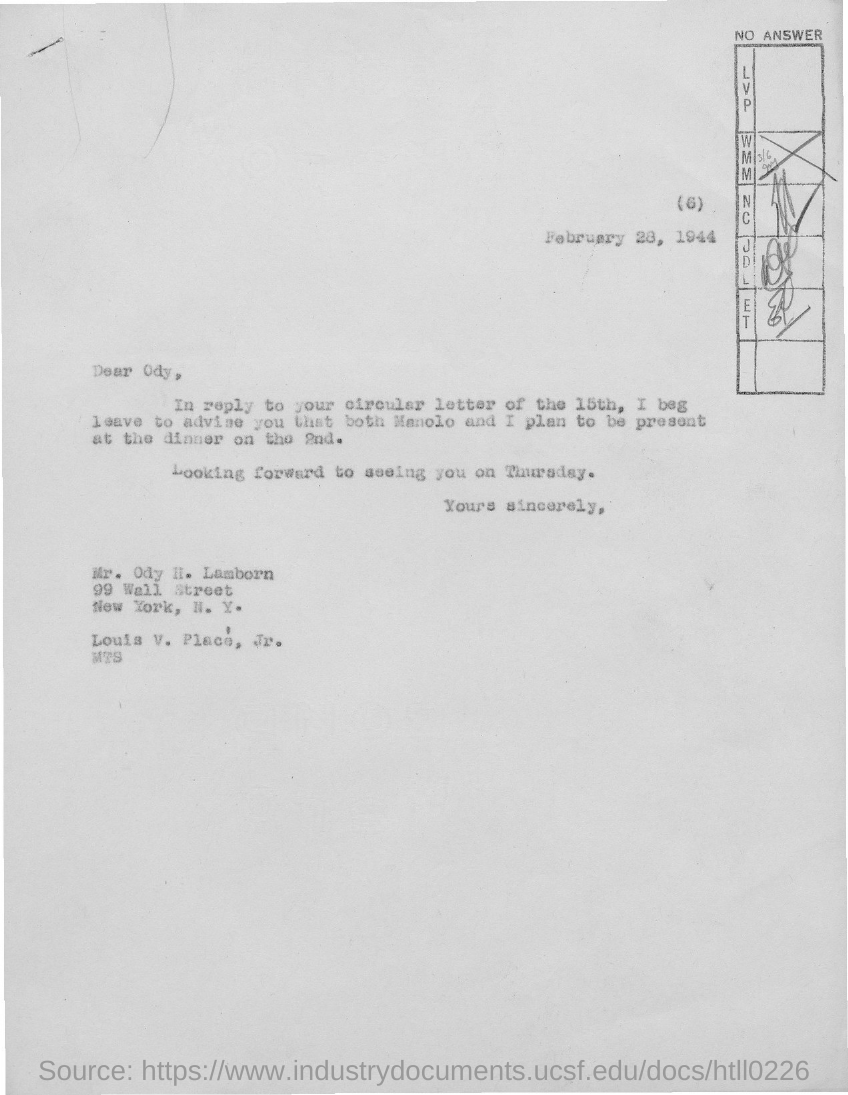What is the date on the document?
Provide a short and direct response. FEBRUARY 28, 1944. Which date is the circular letter from?
Provide a succinct answer. 15TH. To Whom is this letter addressed to?
Offer a terse response. ODY. When is the Dinner?
Provide a short and direct response. 2ND. 